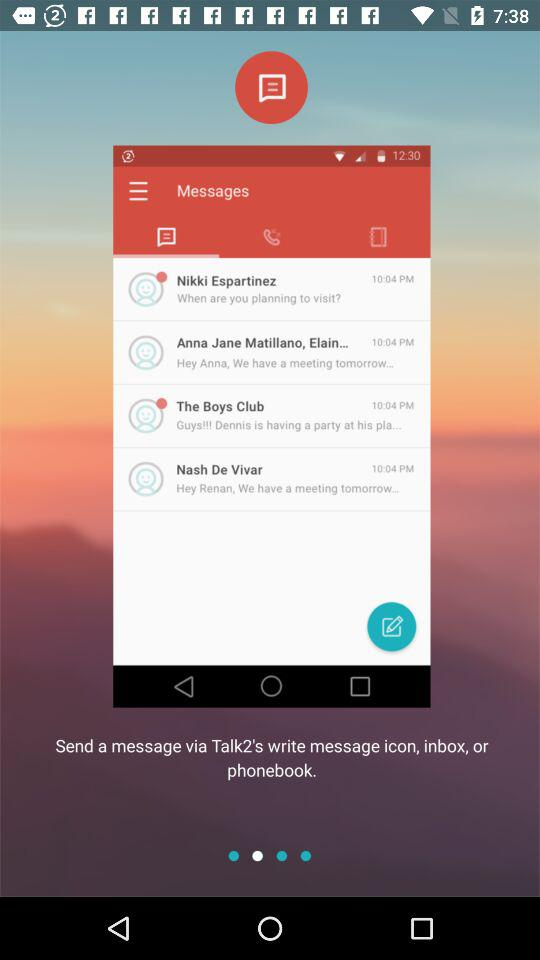What is the message time of "The Boys Club"? The message time is 10:04 PM. 